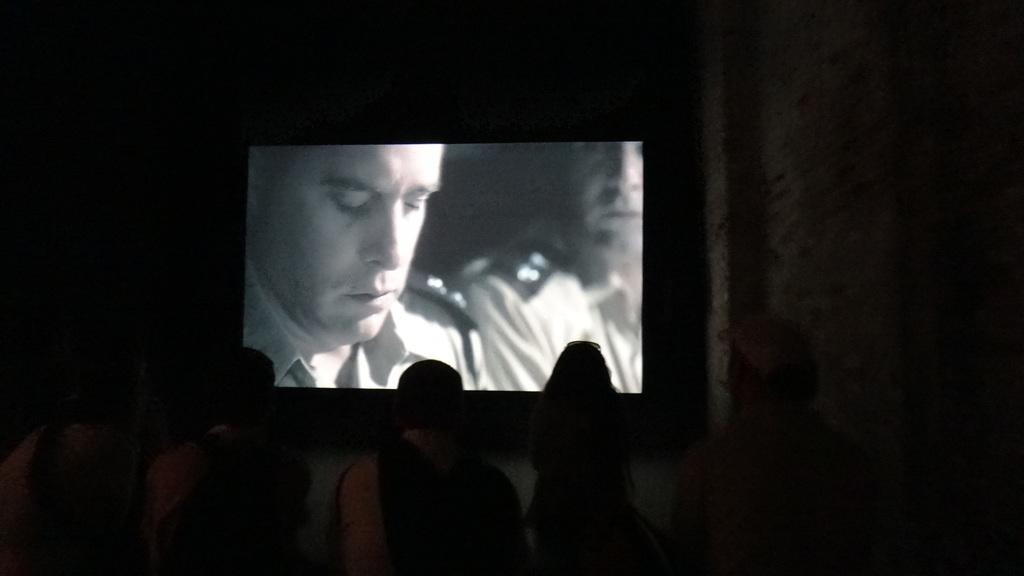How many people are in the image? There is a group of people in the image. What is in front of the group of people? There is a screen in front of the group of people. What can be observed about the background of the image? The background of the image is dark. How many bikes are parked behind the group of people in the image? There is no mention of bikes in the image, so it is not possible to determine how many bikes might be parked behind the group. 